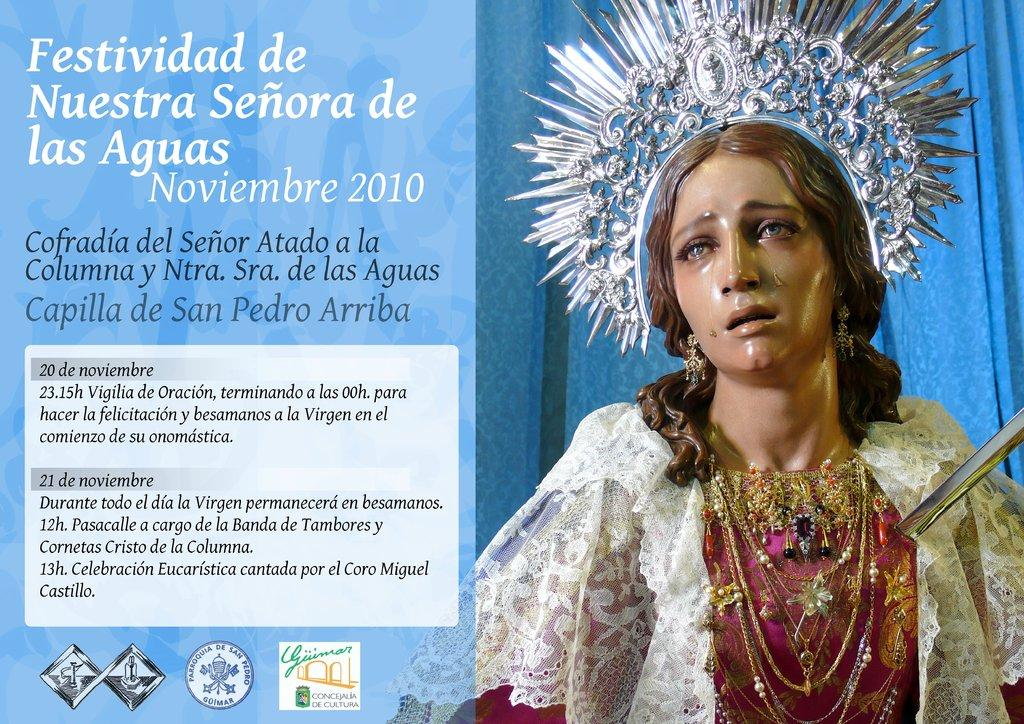What can be found on the right side of the image? There is a statue on the right side of the image. What is located on the left side of the image? There is some text on the left side of the image. What is present at the bottom of the image? There are logos at the bottom of the image. Can you tell me how the statue is talking to the logos in the image? There is no interaction or communication between the statue and the logos in the image; they are separate elements. What type of stem is growing from the text in the image? There is no stem present in the image; the text is not associated with any plant or organic material. 